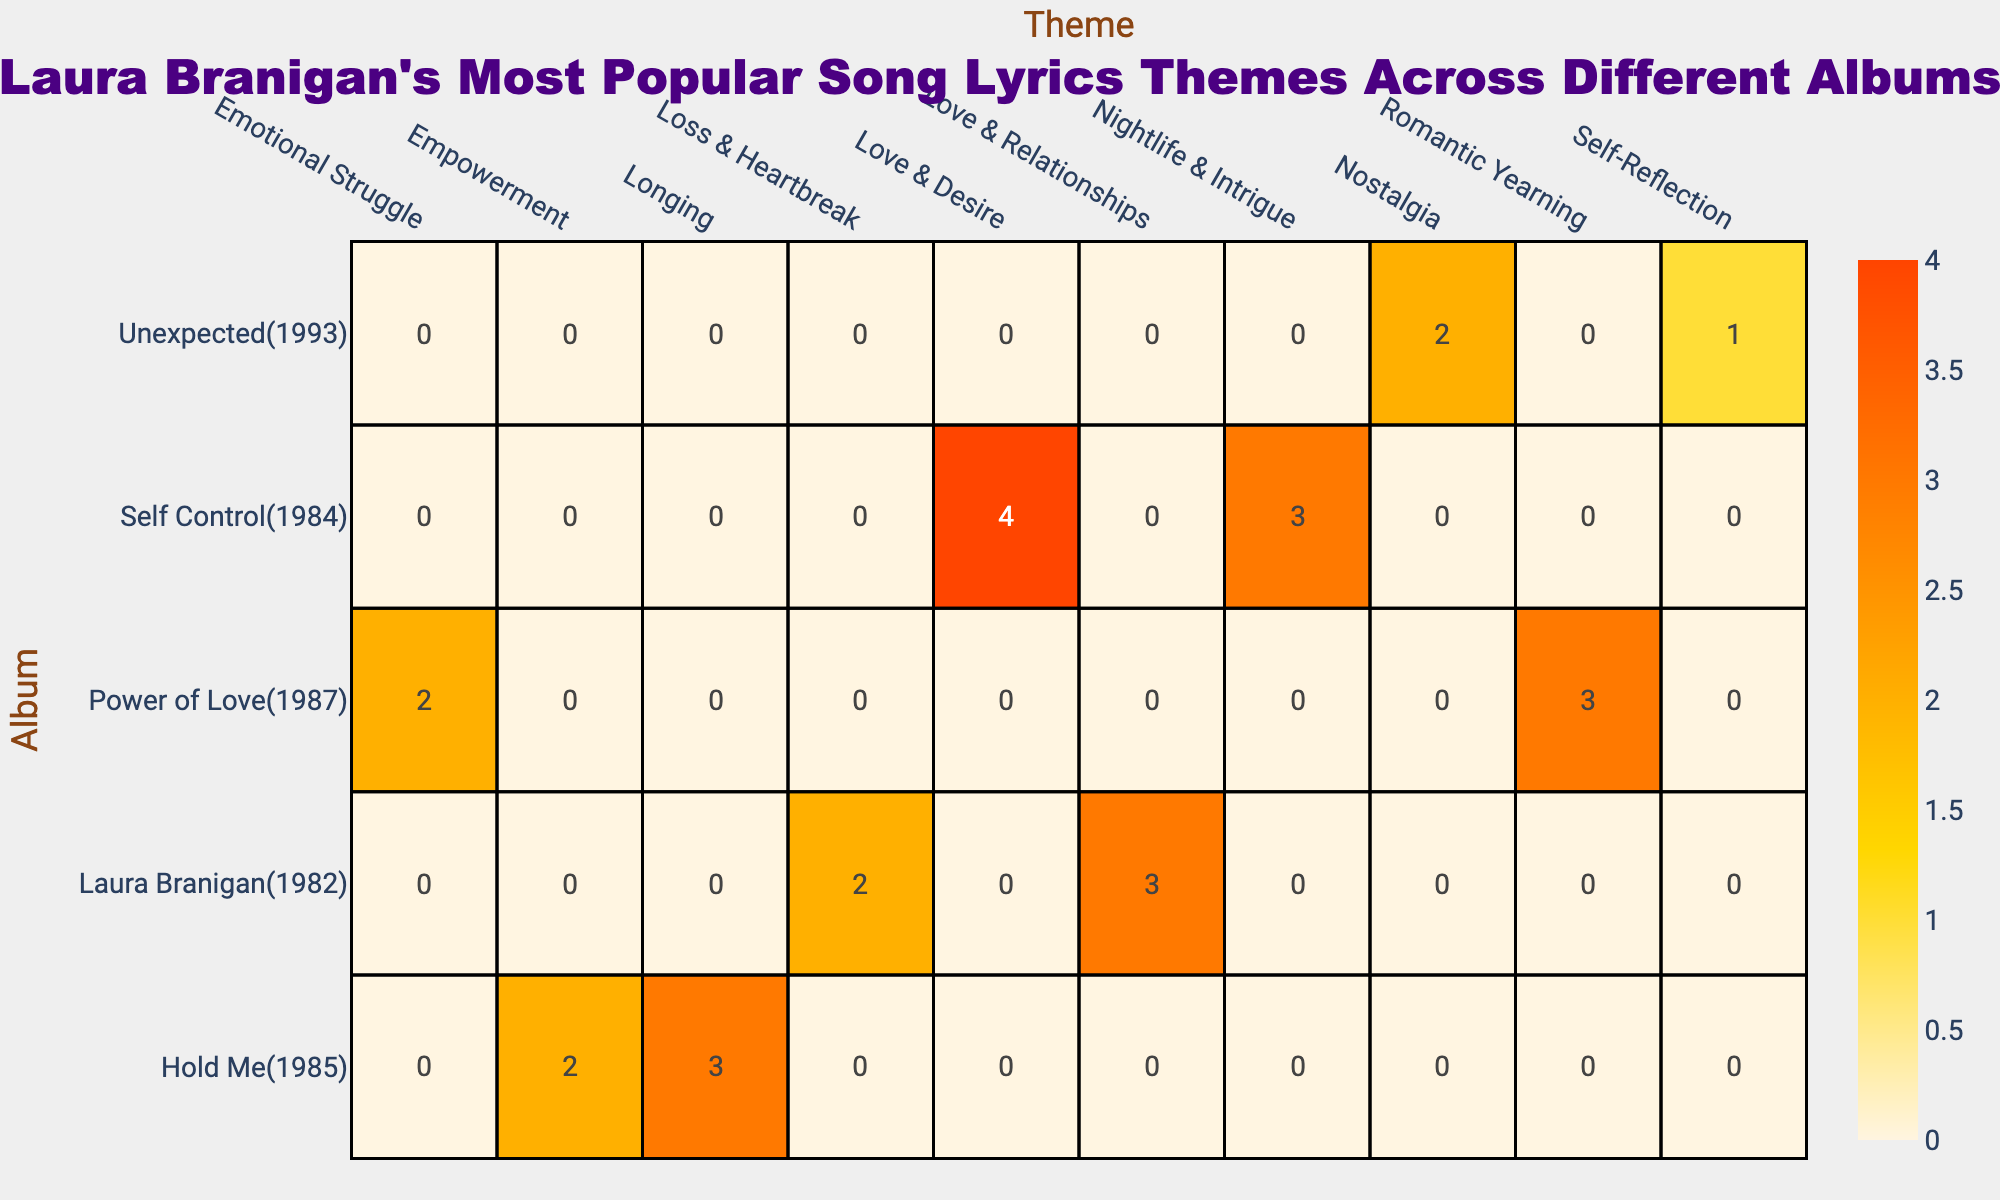What is the theme with the highest song count in the "Self Control" album? In the "Self Control" album, the themes listed are "Nightlife & Intrigue" with 3 songs and "Love & Desire" with 4 songs. Comparing the song counts, "Love & Desire" has the highest count with 4.
Answer: Love & Desire How many songs in total are focused on "Empowerment" across all albums? There are 2 songs related to "Empowerment" in the "Hold Me" album. Since this is the only entry for this theme in the table, the total count is 2.
Answer: 2 Which album has the most themes represented in the table? Looking at the themes for each album: "Laura Branigan" has 2 themes, "Hold Me" has 2 themes, "Self Control" has 2 themes, "Power of Love" has 2 themes, and "Unexpected" has 2 themes. All albums have the same number of themes, with none having more than 2.
Answer: None Is there a theme for the album "Power of Love" that has a count of 3? In the album "Power of Love," there are two themes: "Romantic Yearning" which has 3 songs and "Emotional Struggle" which has 2 songs. Since "Romantic Yearning" indeed has a count of 3, the statement is true.
Answer: Yes What is the total number of songs about "Loss & Heartbreak" as compared to "Romantic Yearning"? "Loss & Heartbreak" in the "Laura Branigan" album has 2 songs, while "Romantic Yearning" in the "Power of Love" album has 3 songs. Adding them together, 2 + 3 equals 5. Hence, 3 is compared against 5.
Answer: 5 